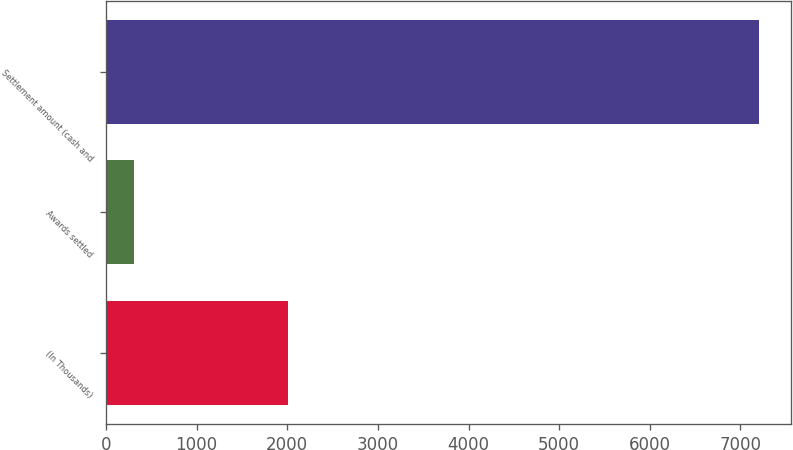Convert chart. <chart><loc_0><loc_0><loc_500><loc_500><bar_chart><fcel>(In Thousands)<fcel>Awards settled<fcel>Settlement amount (cash and<nl><fcel>2011<fcel>305<fcel>7200<nl></chart> 